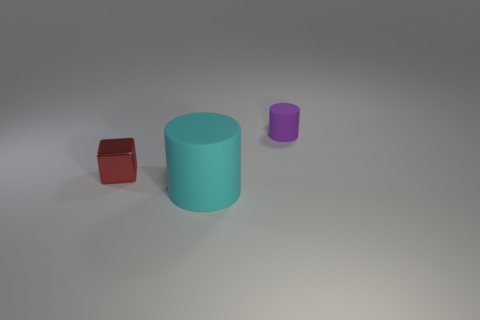There is another thing that is the same size as the purple rubber object; what material is it?
Your answer should be very brief. Metal. Is there a red thing of the same size as the cyan object?
Your answer should be very brief. No. The large thing has what color?
Offer a terse response. Cyan. There is a matte cylinder that is in front of the cylinder behind the red metallic object; what is its color?
Give a very brief answer. Cyan. There is a tiny object to the left of the cylinder that is in front of the small thing that is to the right of the large cyan rubber object; what is its shape?
Your answer should be compact. Cube. How many other large brown cylinders are the same material as the big cylinder?
Keep it short and to the point. 0. There is a red object that is to the left of the big thing; how many small purple things are on the left side of it?
Your answer should be very brief. 0. How many tiny purple matte cylinders are there?
Your response must be concise. 1. Are the tiny purple object and the object that is left of the large cyan thing made of the same material?
Provide a succinct answer. No. There is a matte object that is behind the big rubber cylinder; is it the same color as the small block?
Make the answer very short. No. 